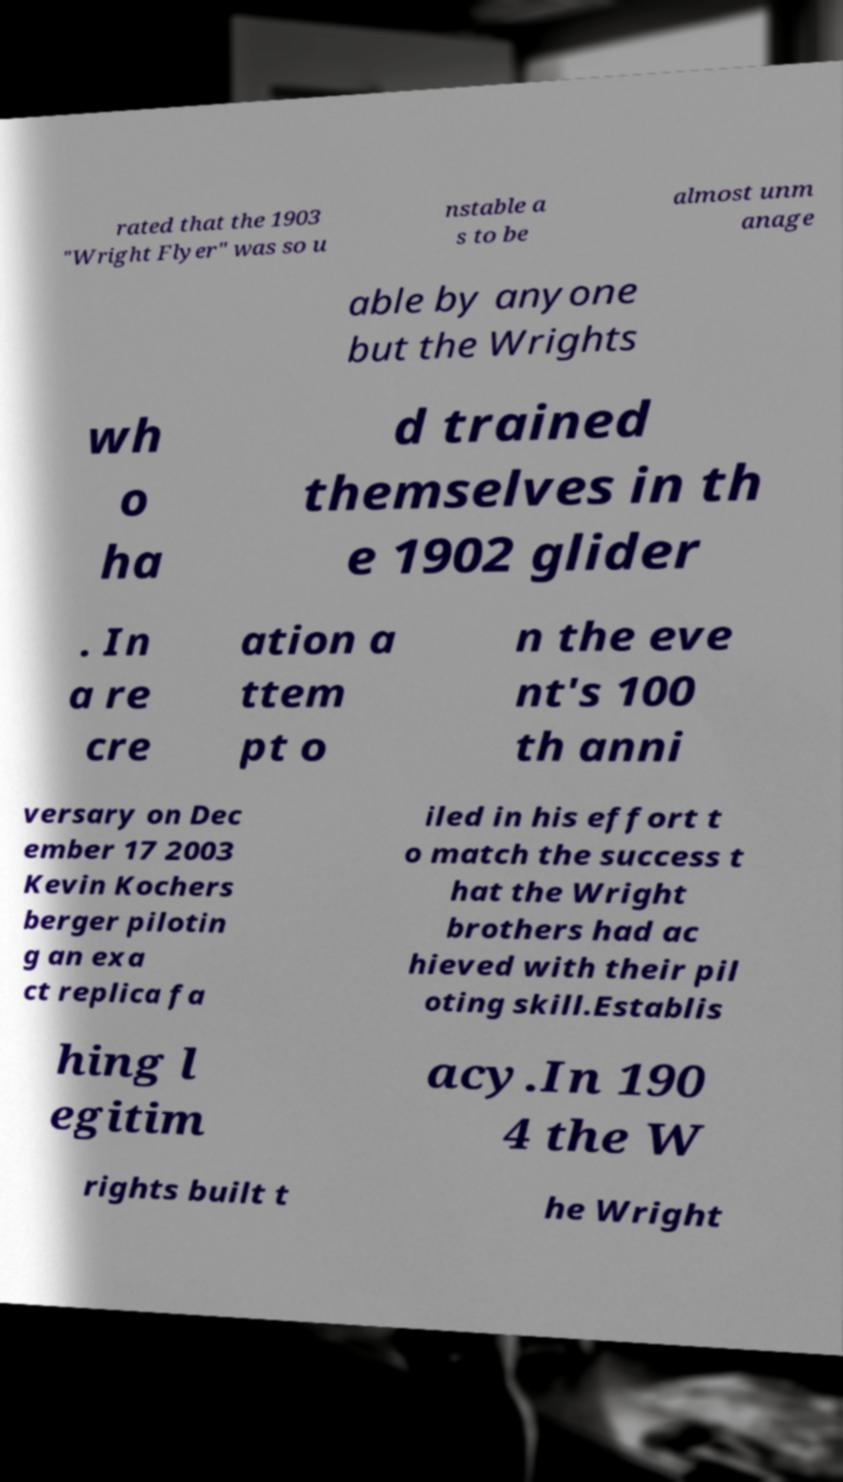I need the written content from this picture converted into text. Can you do that? rated that the 1903 "Wright Flyer" was so u nstable a s to be almost unm anage able by anyone but the Wrights wh o ha d trained themselves in th e 1902 glider . In a re cre ation a ttem pt o n the eve nt's 100 th anni versary on Dec ember 17 2003 Kevin Kochers berger pilotin g an exa ct replica fa iled in his effort t o match the success t hat the Wright brothers had ac hieved with their pil oting skill.Establis hing l egitim acy.In 190 4 the W rights built t he Wright 